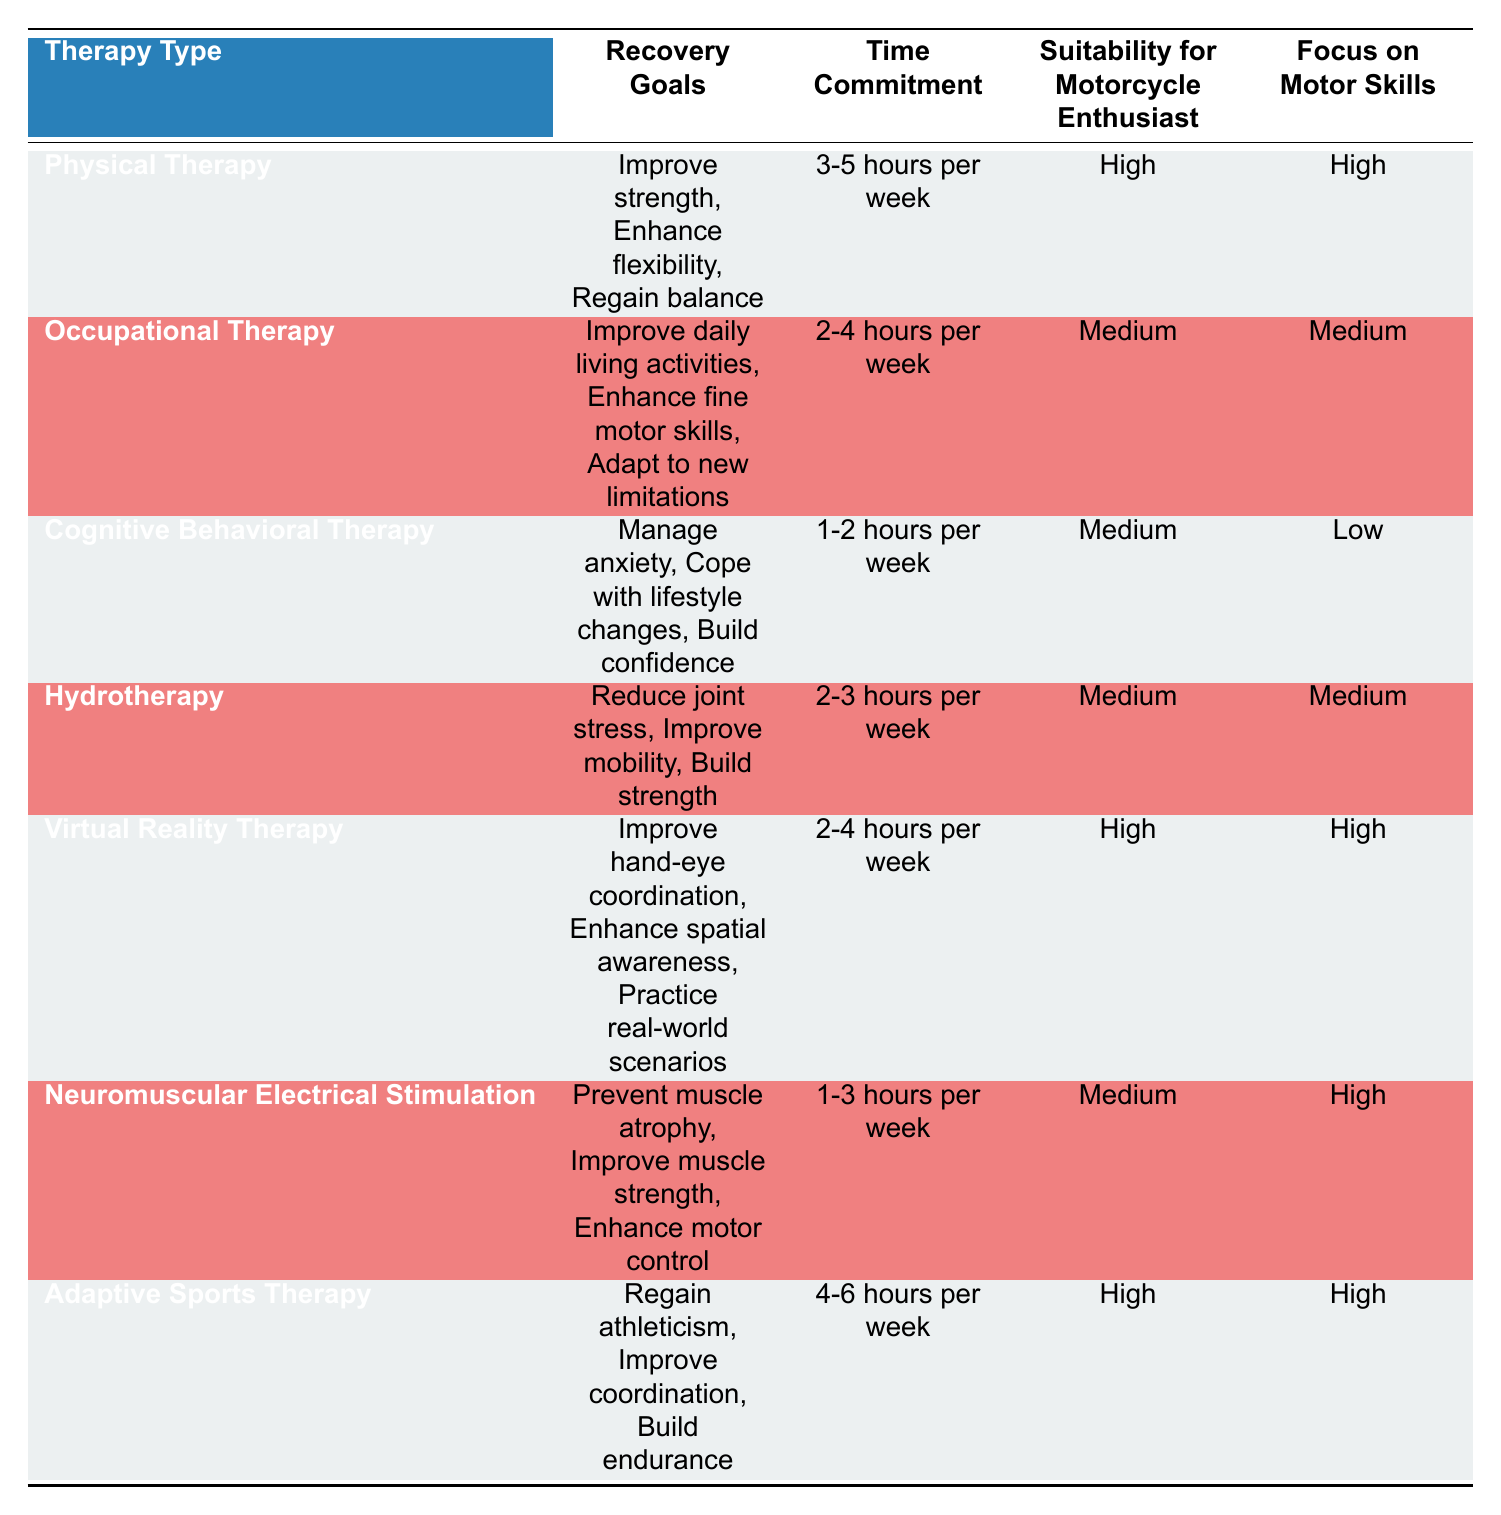What is the time commitment for Physical Therapy? Referring to the table, Physical Therapy requires a time commitment of 3-5 hours per week.
Answer: 3-5 hours per week Which therapy has the highest focus on motor skills? In the table, Adaptive Sports Therapy, Virtual Reality Therapy, and Physical Therapy all have a "High" focus on motor skills. Among these, Adaptive Sports Therapy has the highest time commitment of 4-6 hours per week.
Answer: Adaptive Sports Therapy Does Cognitive Behavioral Therapy have a medium suitability for motorcycle enthusiasts? By checking the suitability column for Cognitive Behavioral Therapy, it indicates "Medium."
Answer: Yes What are the recovery goals of Hydrotherapy? Looking at the table, Hydrotherapy has the recovery goals of reducing joint stress, improving mobility, and building strength.
Answer: Reduce joint stress, improve mobility, build strength Which therapy requires the least amount of time commitment? Reviewing the time commitment column, Cognitive Behavioral Therapy has the lowest commitment at 1-2 hours per week.
Answer: 1-2 hours per week If you want to improve both strength and coordination, which therapies should you consider? Physical Therapy focuses on improving strength while Adaptive Sports Therapy focuses on coordination. Therefore, both therapies should be considered to meet these goals.
Answer: Physical Therapy, Adaptive Sports Therapy How many therapies are suitable for motorcycle enthusiasts with a high focus on motor skills? From the table, Physical Therapy, Virtual Reality Therapy, and Adaptive Sports Therapy are suitable for motorcycle enthusiasts with a high focus on motor skills, making a total of three therapies.
Answer: 3 What is the average time commitment of all therapies listed? To find the average time commitment, we first convert the various ranges into their numerical equivalents: for example, Physical Therapy (4 hours), Occupational Therapy (3 hours), Cognitive Behavioral Therapy (1.5 hours), Hydrotherapy (2.5 hours), Virtual Reality Therapy (3 hours), Neuromuscular Electrical Stimulation (2 hours), Adaptive Sports Therapy (5 hours). Adding these values gives 21 hours for 7 therapies. The average time commitment is computed as 21/7 = 3 hours per week.
Answer: 3 hours per week Is there any therapy that focuses on hand-eye coordination? Yes, Virtual Reality Therapy specifically includes "Improve hand-eye coordination" as one of its recovery goals.
Answer: Yes 